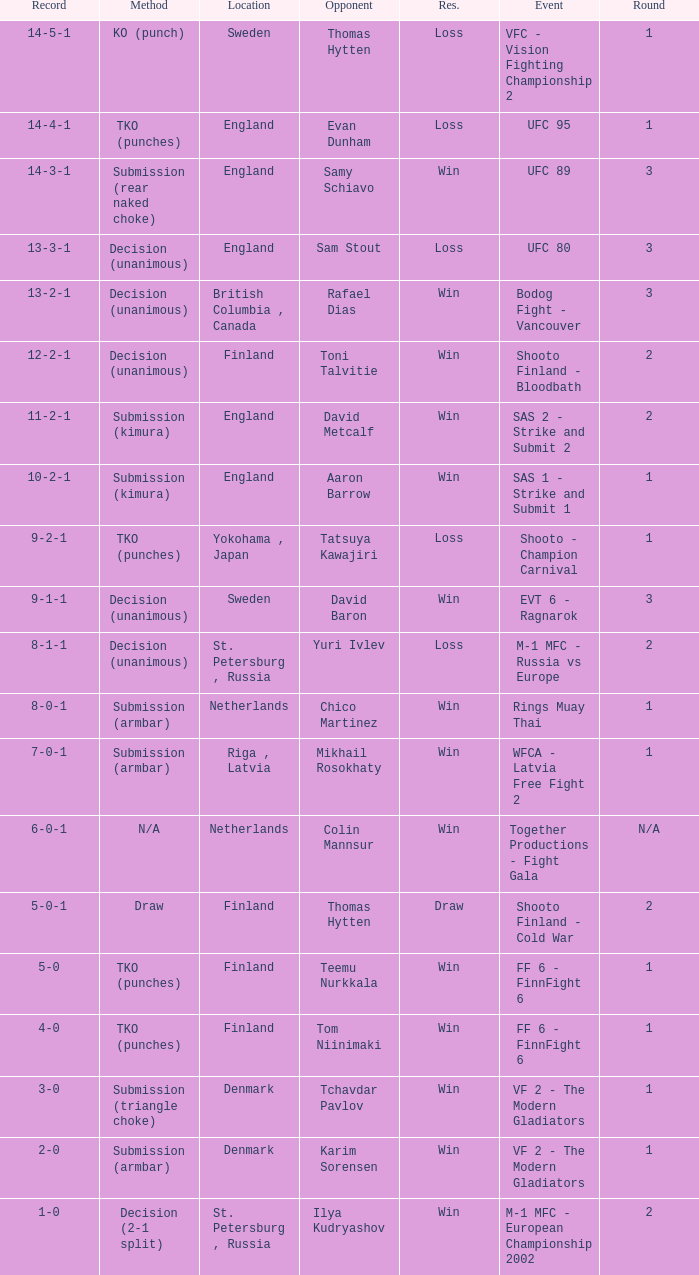What is the round in Finland with a draw for method? 2.0. 